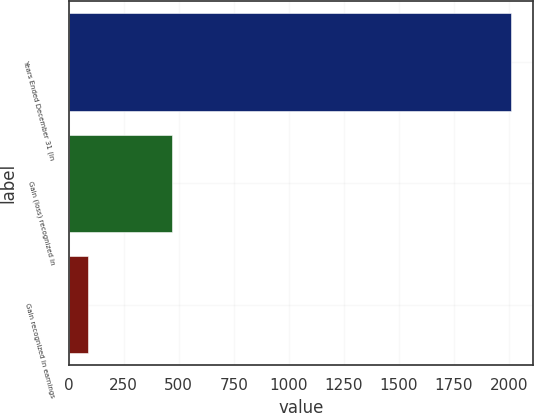Convert chart to OTSL. <chart><loc_0><loc_0><loc_500><loc_500><bar_chart><fcel>Years Ended December 31 (in<fcel>Gain (loss) recognized in<fcel>Gain recognized in earnings<nl><fcel>2009<fcel>471.4<fcel>87<nl></chart> 